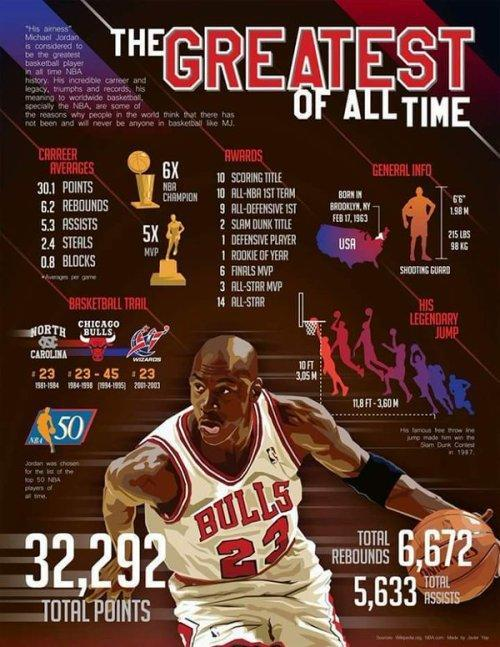What was the weight of Michael Jordan (in pounds)?
Answer the question with a short phrase. 215 lbs What was the height of Michael Jordan (in meters)? 1.98 What was Michael Jordon's jersey number when he played for the North Carolina team? # 23 What was Michael Jordan's overall score? 32,292 What is the height (in feet) of the basketball hoop from the ground? 10 ft Which award did Michael Jordan get 5 times? MVP How many times did Michael Jordan win NBA Championship? 6 For which team did Michael Jordan play with jersey number 45? Chicago Bulls 